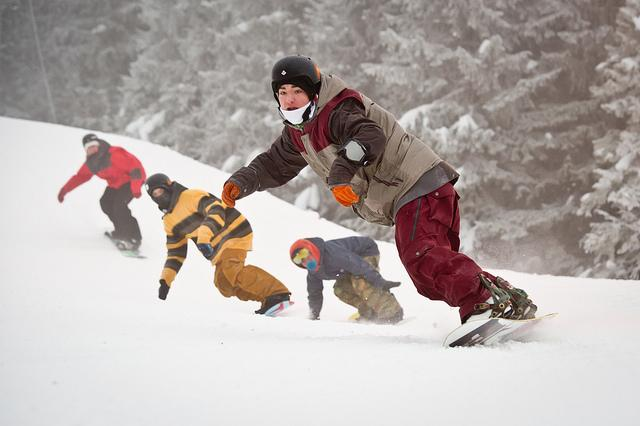Why are the men leaning to one side?

Choices:
A) to turn
B) to dance
C) to exercise
D) to wrestle to turn 